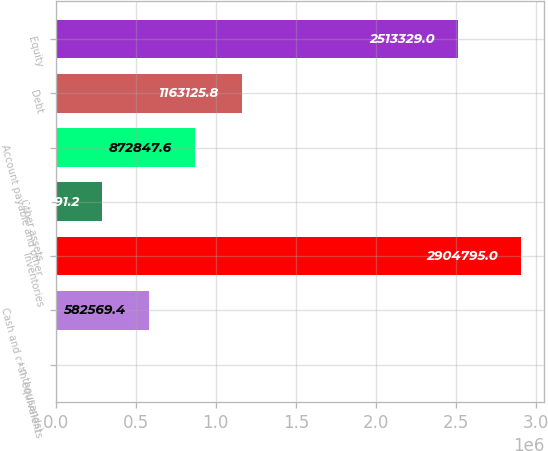Convert chart to OTSL. <chart><loc_0><loc_0><loc_500><loc_500><bar_chart><fcel>(In thousands)<fcel>Cash and cash equivalents<fcel>Inventories<fcel>Other assets<fcel>Account payable and other<fcel>Debt<fcel>Equity<nl><fcel>2013<fcel>582569<fcel>2.9048e+06<fcel>292291<fcel>872848<fcel>1.16313e+06<fcel>2.51333e+06<nl></chart> 